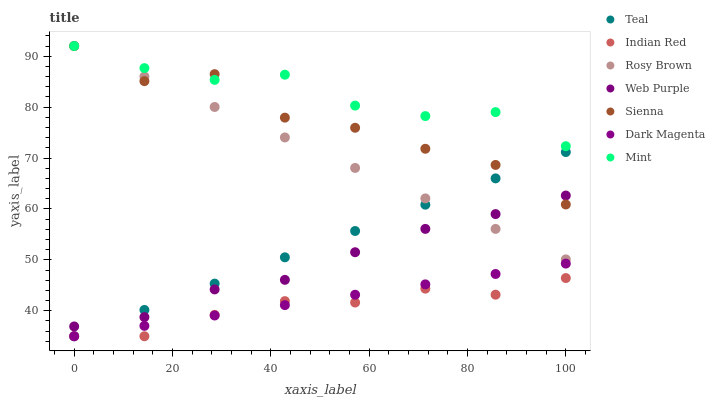Does Indian Red have the minimum area under the curve?
Answer yes or no. Yes. Does Mint have the maximum area under the curve?
Answer yes or no. Yes. Does Rosy Brown have the minimum area under the curve?
Answer yes or no. No. Does Rosy Brown have the maximum area under the curve?
Answer yes or no. No. Is Dark Magenta the smoothest?
Answer yes or no. Yes. Is Sienna the roughest?
Answer yes or no. Yes. Is Rosy Brown the smoothest?
Answer yes or no. No. Is Rosy Brown the roughest?
Answer yes or no. No. Does Teal have the lowest value?
Answer yes or no. Yes. Does Rosy Brown have the lowest value?
Answer yes or no. No. Does Mint have the highest value?
Answer yes or no. Yes. Does Web Purple have the highest value?
Answer yes or no. No. Is Web Purple less than Mint?
Answer yes or no. Yes. Is Mint greater than Teal?
Answer yes or no. Yes. Does Sienna intersect Web Purple?
Answer yes or no. Yes. Is Sienna less than Web Purple?
Answer yes or no. No. Is Sienna greater than Web Purple?
Answer yes or no. No. Does Web Purple intersect Mint?
Answer yes or no. No. 